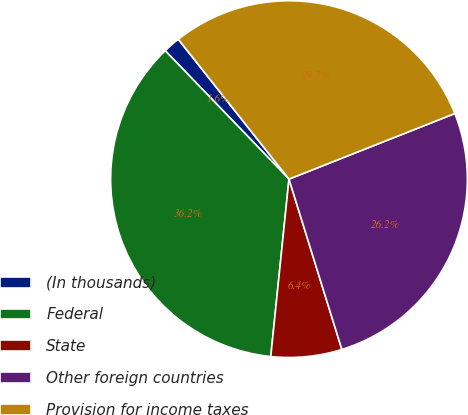Convert chart to OTSL. <chart><loc_0><loc_0><loc_500><loc_500><pie_chart><fcel>(In thousands)<fcel>Federal<fcel>State<fcel>Other foreign countries<fcel>Provision for income taxes<nl><fcel>1.55%<fcel>36.16%<fcel>6.42%<fcel>26.2%<fcel>29.66%<nl></chart> 